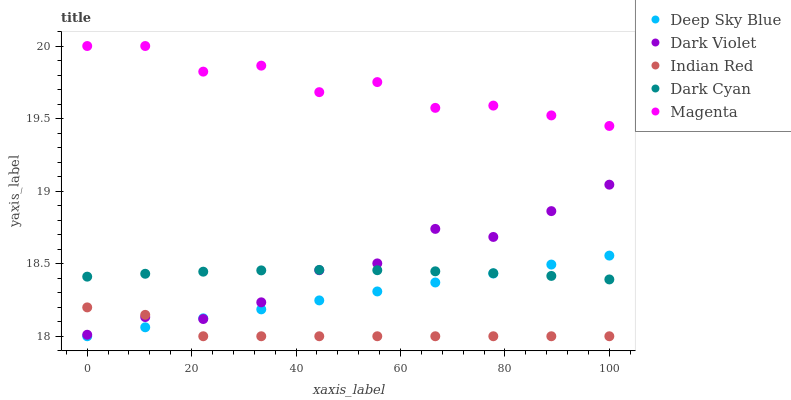Does Indian Red have the minimum area under the curve?
Answer yes or no. Yes. Does Magenta have the maximum area under the curve?
Answer yes or no. Yes. Does Dark Cyan have the minimum area under the curve?
Answer yes or no. No. Does Dark Cyan have the maximum area under the curve?
Answer yes or no. No. Is Deep Sky Blue the smoothest?
Answer yes or no. Yes. Is Magenta the roughest?
Answer yes or no. Yes. Is Dark Cyan the smoothest?
Answer yes or no. No. Is Dark Cyan the roughest?
Answer yes or no. No. Does Indian Red have the lowest value?
Answer yes or no. Yes. Does Dark Cyan have the lowest value?
Answer yes or no. No. Does Magenta have the highest value?
Answer yes or no. Yes. Does Dark Cyan have the highest value?
Answer yes or no. No. Is Indian Red less than Magenta?
Answer yes or no. Yes. Is Dark Cyan greater than Indian Red?
Answer yes or no. Yes. Does Dark Cyan intersect Dark Violet?
Answer yes or no. Yes. Is Dark Cyan less than Dark Violet?
Answer yes or no. No. Is Dark Cyan greater than Dark Violet?
Answer yes or no. No. Does Indian Red intersect Magenta?
Answer yes or no. No. 